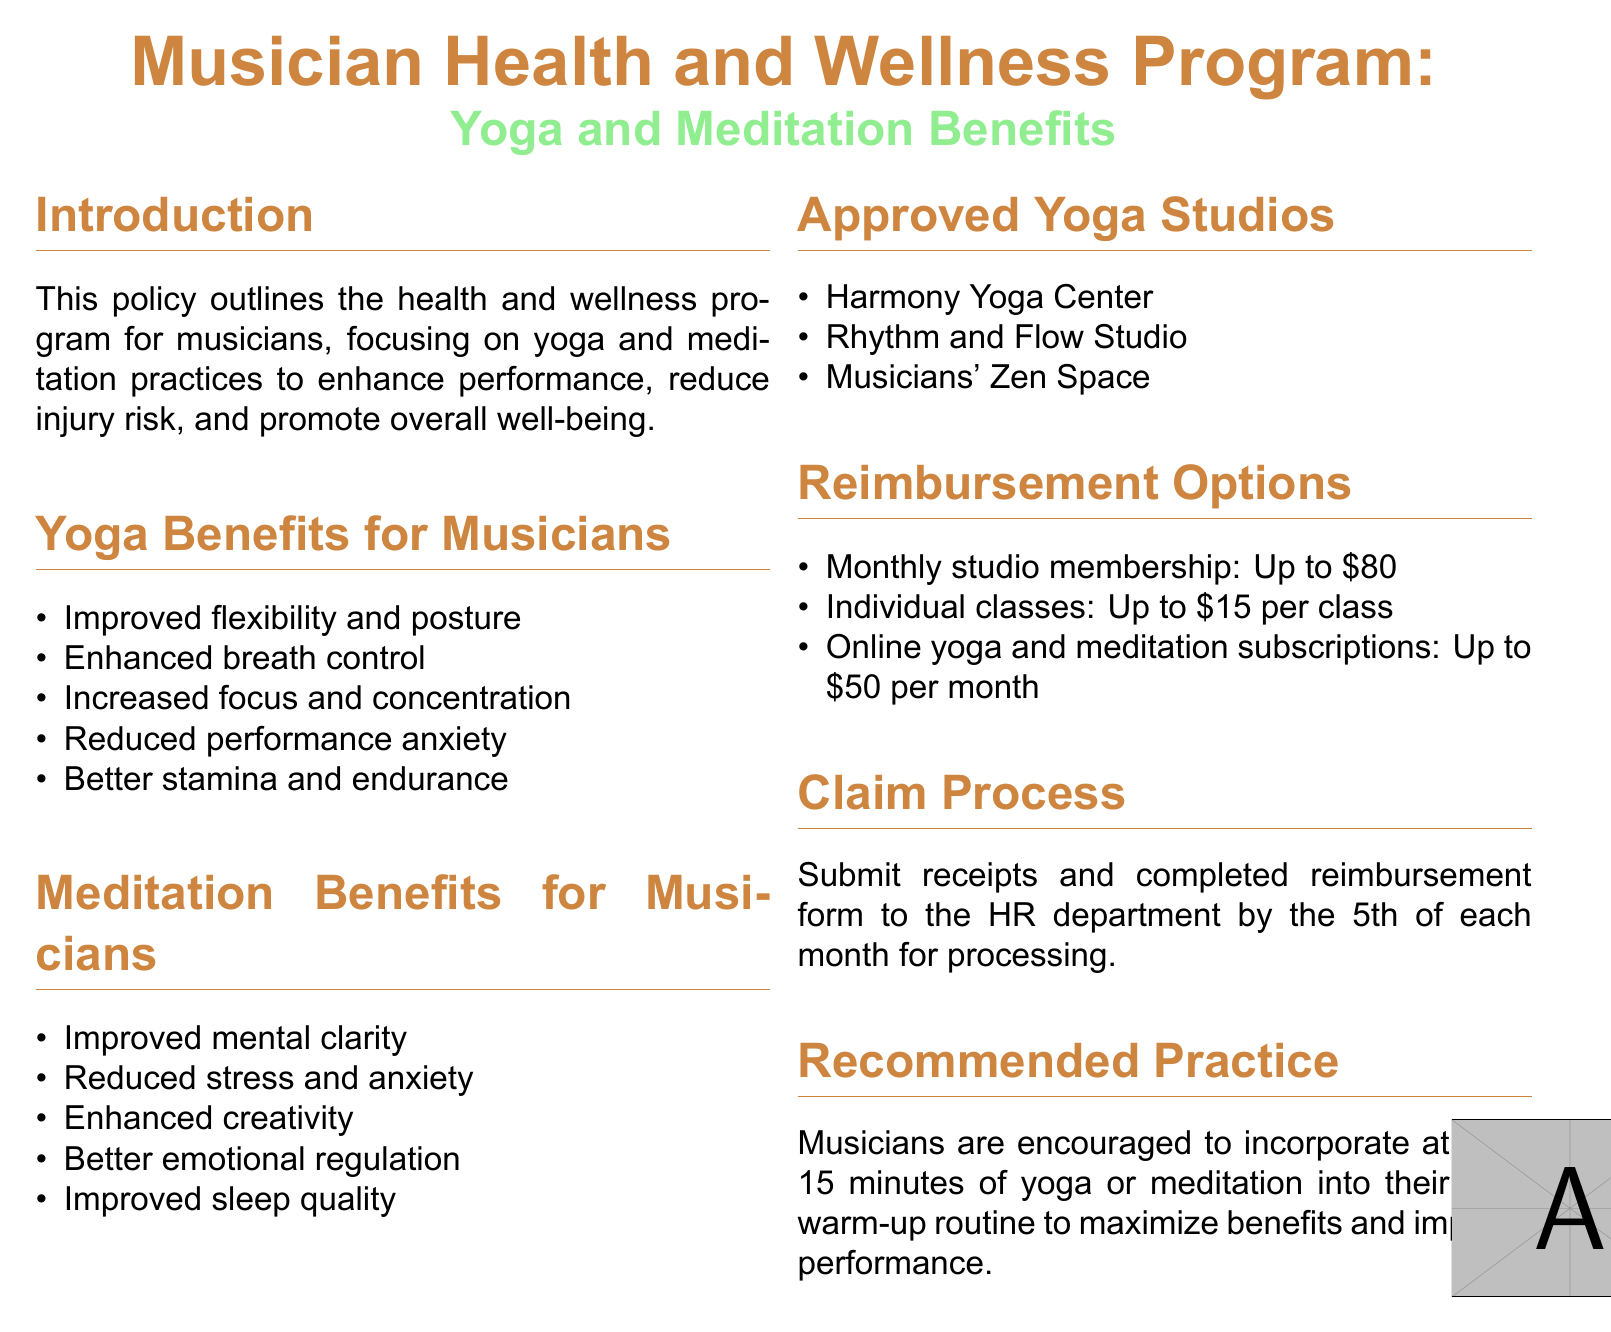What are the benefits of yoga for musicians? The section lists specific benefits such as improved flexibility and posture, enhanced breath control, increased focus and concentration, reduced performance anxiety, and better stamina and endurance.
Answer: Improved flexibility and posture, enhanced breath control, increased focus and concentration, reduced performance anxiety, better stamina and endurance What is the reimbursement amount for a monthly studio membership? The document specifies the maximum amount that can be reimbursed for a monthly studio membership under the reimbursement options.
Answer: Up to 80 dollars Name one approved yoga studio. The document provides a list of approved yoga studios specifically for musicians, with the names of each studio listed.
Answer: Harmony Yoga Center What is the recommended daily practice duration for musicians? The document advises musicians on how long they should incorporate yoga or meditation into their daily routine to maximize benefits.
Answer: At least 15 minutes What do musicians need to submit for the claim process? The claim process section explains what needs to be submitted to the HR department in order to receive reimbursement.
Answer: Receipts and completed reimbursement form 